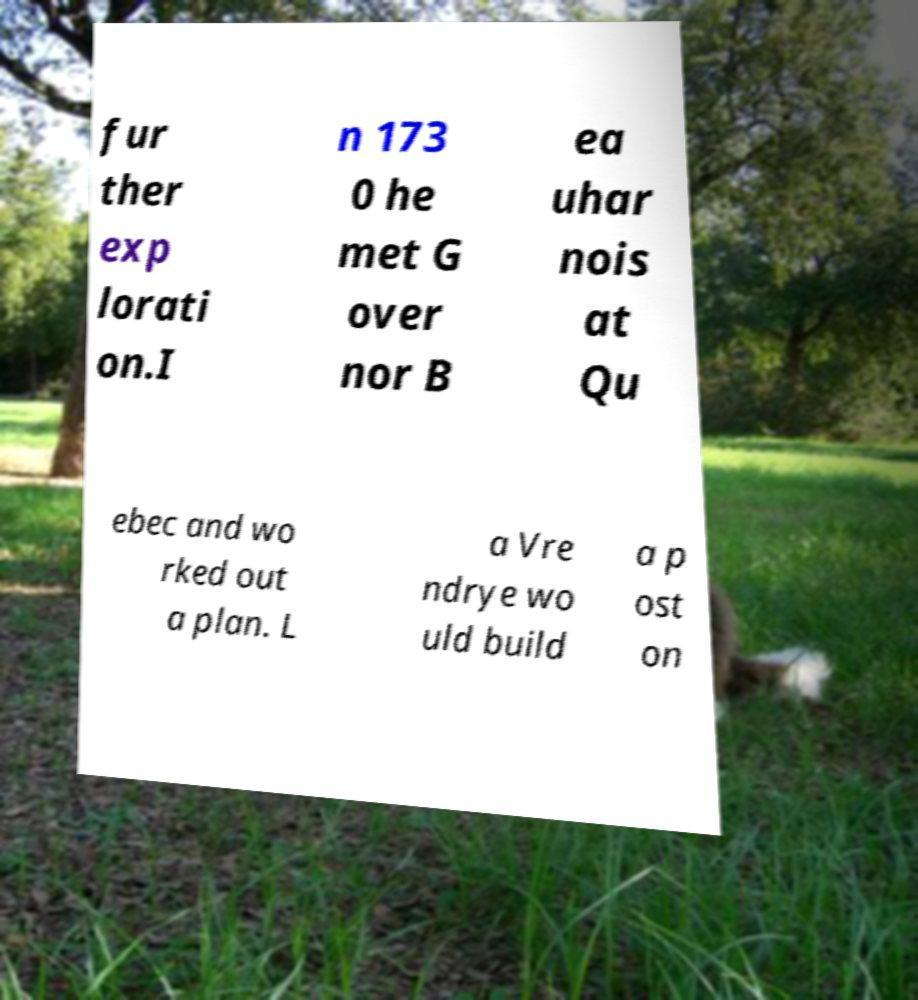What messages or text are displayed in this image? I need them in a readable, typed format. fur ther exp lorati on.I n 173 0 he met G over nor B ea uhar nois at Qu ebec and wo rked out a plan. L a Vre ndrye wo uld build a p ost on 